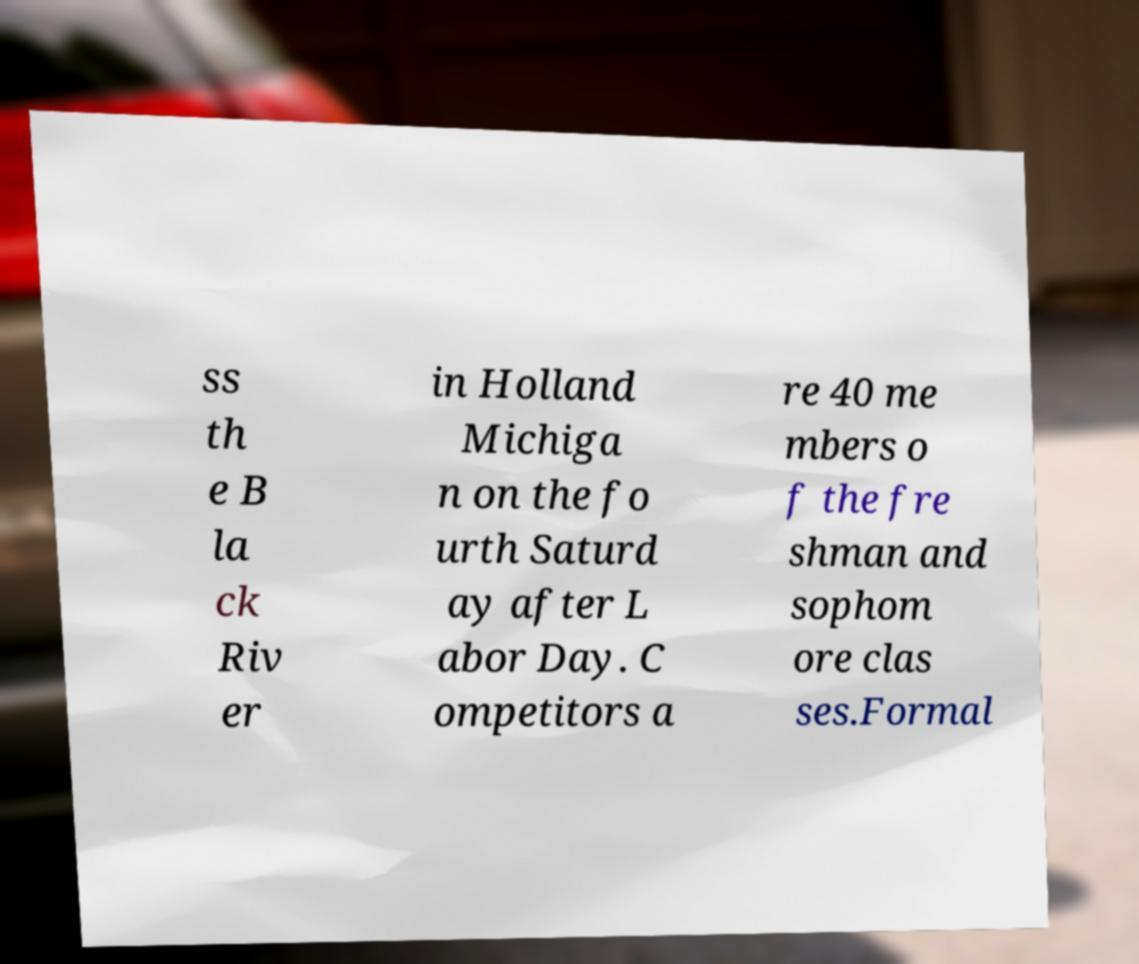Could you assist in decoding the text presented in this image and type it out clearly? ss th e B la ck Riv er in Holland Michiga n on the fo urth Saturd ay after L abor Day. C ompetitors a re 40 me mbers o f the fre shman and sophom ore clas ses.Formal 